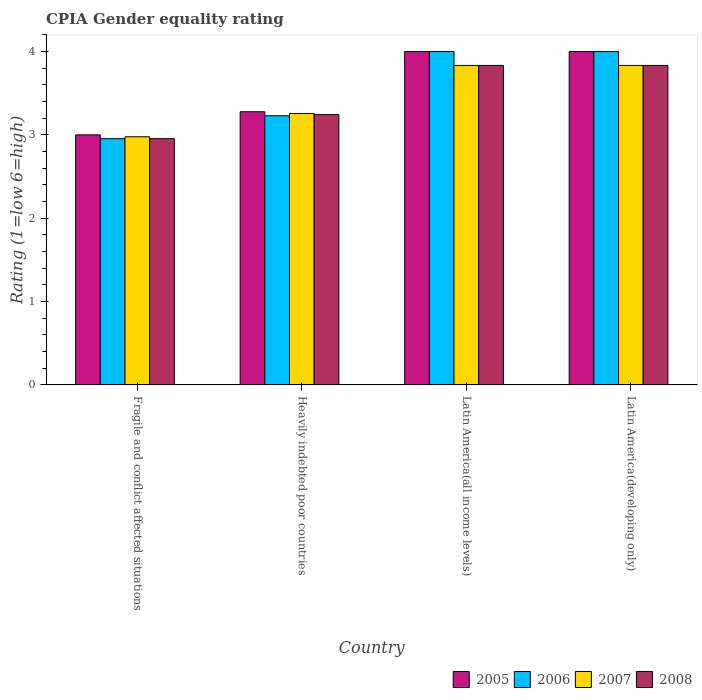How many different coloured bars are there?
Provide a short and direct response. 4. Are the number of bars on each tick of the X-axis equal?
Ensure brevity in your answer.  Yes. How many bars are there on the 4th tick from the left?
Your response must be concise. 4. What is the label of the 4th group of bars from the left?
Provide a succinct answer. Latin America(developing only). In how many cases, is the number of bars for a given country not equal to the number of legend labels?
Ensure brevity in your answer.  0. What is the CPIA rating in 2007 in Latin America(developing only)?
Provide a succinct answer. 3.83. Across all countries, what is the maximum CPIA rating in 2008?
Your answer should be compact. 3.83. Across all countries, what is the minimum CPIA rating in 2007?
Offer a terse response. 2.98. In which country was the CPIA rating in 2005 maximum?
Make the answer very short. Latin America(all income levels). In which country was the CPIA rating in 2007 minimum?
Ensure brevity in your answer.  Fragile and conflict affected situations. What is the total CPIA rating in 2008 in the graph?
Your answer should be very brief. 13.86. What is the difference between the CPIA rating in 2008 in Heavily indebted poor countries and that in Latin America(developing only)?
Make the answer very short. -0.59. What is the difference between the CPIA rating in 2006 in Fragile and conflict affected situations and the CPIA rating in 2005 in Latin America(all income levels)?
Offer a terse response. -1.05. What is the average CPIA rating in 2005 per country?
Offer a very short reply. 3.57. What is the difference between the CPIA rating of/in 2007 and CPIA rating of/in 2005 in Latin America(all income levels)?
Your answer should be very brief. -0.17. In how many countries, is the CPIA rating in 2005 greater than 3?
Make the answer very short. 3. What is the ratio of the CPIA rating in 2007 in Heavily indebted poor countries to that in Latin America(all income levels)?
Offer a very short reply. 0.85. Is the CPIA rating in 2007 in Fragile and conflict affected situations less than that in Latin America(all income levels)?
Your response must be concise. Yes. Is the difference between the CPIA rating in 2007 in Fragile and conflict affected situations and Heavily indebted poor countries greater than the difference between the CPIA rating in 2005 in Fragile and conflict affected situations and Heavily indebted poor countries?
Keep it short and to the point. No. What is the difference between the highest and the second highest CPIA rating in 2008?
Provide a succinct answer. -0.59. What is the difference between the highest and the lowest CPIA rating in 2007?
Offer a very short reply. 0.86. In how many countries, is the CPIA rating in 2007 greater than the average CPIA rating in 2007 taken over all countries?
Make the answer very short. 2. What does the 2nd bar from the left in Latin America(developing only) represents?
Your response must be concise. 2006. How many bars are there?
Offer a very short reply. 16. How many countries are there in the graph?
Provide a succinct answer. 4. Are the values on the major ticks of Y-axis written in scientific E-notation?
Offer a terse response. No. Does the graph contain grids?
Keep it short and to the point. No. What is the title of the graph?
Provide a short and direct response. CPIA Gender equality rating. What is the label or title of the X-axis?
Make the answer very short. Country. What is the label or title of the Y-axis?
Provide a short and direct response. Rating (1=low 6=high). What is the Rating (1=low 6=high) of 2005 in Fragile and conflict affected situations?
Your response must be concise. 3. What is the Rating (1=low 6=high) in 2006 in Fragile and conflict affected situations?
Ensure brevity in your answer.  2.95. What is the Rating (1=low 6=high) in 2007 in Fragile and conflict affected situations?
Your answer should be compact. 2.98. What is the Rating (1=low 6=high) in 2008 in Fragile and conflict affected situations?
Provide a succinct answer. 2.95. What is the Rating (1=low 6=high) of 2005 in Heavily indebted poor countries?
Keep it short and to the point. 3.28. What is the Rating (1=low 6=high) of 2006 in Heavily indebted poor countries?
Your answer should be compact. 3.23. What is the Rating (1=low 6=high) of 2007 in Heavily indebted poor countries?
Your answer should be very brief. 3.26. What is the Rating (1=low 6=high) in 2008 in Heavily indebted poor countries?
Your response must be concise. 3.24. What is the Rating (1=low 6=high) of 2006 in Latin America(all income levels)?
Your response must be concise. 4. What is the Rating (1=low 6=high) of 2007 in Latin America(all income levels)?
Ensure brevity in your answer.  3.83. What is the Rating (1=low 6=high) of 2008 in Latin America(all income levels)?
Offer a very short reply. 3.83. What is the Rating (1=low 6=high) in 2006 in Latin America(developing only)?
Offer a terse response. 4. What is the Rating (1=low 6=high) in 2007 in Latin America(developing only)?
Offer a terse response. 3.83. What is the Rating (1=low 6=high) of 2008 in Latin America(developing only)?
Offer a terse response. 3.83. Across all countries, what is the maximum Rating (1=low 6=high) in 2007?
Make the answer very short. 3.83. Across all countries, what is the maximum Rating (1=low 6=high) of 2008?
Offer a very short reply. 3.83. Across all countries, what is the minimum Rating (1=low 6=high) of 2006?
Offer a very short reply. 2.95. Across all countries, what is the minimum Rating (1=low 6=high) of 2007?
Your answer should be compact. 2.98. Across all countries, what is the minimum Rating (1=low 6=high) in 2008?
Provide a short and direct response. 2.95. What is the total Rating (1=low 6=high) in 2005 in the graph?
Your answer should be very brief. 14.28. What is the total Rating (1=low 6=high) in 2006 in the graph?
Make the answer very short. 14.18. What is the total Rating (1=low 6=high) of 2007 in the graph?
Ensure brevity in your answer.  13.9. What is the total Rating (1=low 6=high) in 2008 in the graph?
Your response must be concise. 13.86. What is the difference between the Rating (1=low 6=high) in 2005 in Fragile and conflict affected situations and that in Heavily indebted poor countries?
Your response must be concise. -0.28. What is the difference between the Rating (1=low 6=high) in 2006 in Fragile and conflict affected situations and that in Heavily indebted poor countries?
Keep it short and to the point. -0.28. What is the difference between the Rating (1=low 6=high) in 2007 in Fragile and conflict affected situations and that in Heavily indebted poor countries?
Your answer should be compact. -0.28. What is the difference between the Rating (1=low 6=high) in 2008 in Fragile and conflict affected situations and that in Heavily indebted poor countries?
Your answer should be compact. -0.29. What is the difference between the Rating (1=low 6=high) in 2005 in Fragile and conflict affected situations and that in Latin America(all income levels)?
Ensure brevity in your answer.  -1. What is the difference between the Rating (1=low 6=high) in 2006 in Fragile and conflict affected situations and that in Latin America(all income levels)?
Your response must be concise. -1.05. What is the difference between the Rating (1=low 6=high) in 2007 in Fragile and conflict affected situations and that in Latin America(all income levels)?
Give a very brief answer. -0.86. What is the difference between the Rating (1=low 6=high) in 2008 in Fragile and conflict affected situations and that in Latin America(all income levels)?
Provide a succinct answer. -0.88. What is the difference between the Rating (1=low 6=high) of 2005 in Fragile and conflict affected situations and that in Latin America(developing only)?
Provide a short and direct response. -1. What is the difference between the Rating (1=low 6=high) of 2006 in Fragile and conflict affected situations and that in Latin America(developing only)?
Provide a short and direct response. -1.05. What is the difference between the Rating (1=low 6=high) of 2007 in Fragile and conflict affected situations and that in Latin America(developing only)?
Ensure brevity in your answer.  -0.86. What is the difference between the Rating (1=low 6=high) in 2008 in Fragile and conflict affected situations and that in Latin America(developing only)?
Offer a terse response. -0.88. What is the difference between the Rating (1=low 6=high) in 2005 in Heavily indebted poor countries and that in Latin America(all income levels)?
Offer a very short reply. -0.72. What is the difference between the Rating (1=low 6=high) in 2006 in Heavily indebted poor countries and that in Latin America(all income levels)?
Keep it short and to the point. -0.77. What is the difference between the Rating (1=low 6=high) of 2007 in Heavily indebted poor countries and that in Latin America(all income levels)?
Provide a short and direct response. -0.58. What is the difference between the Rating (1=low 6=high) of 2008 in Heavily indebted poor countries and that in Latin America(all income levels)?
Offer a terse response. -0.59. What is the difference between the Rating (1=low 6=high) of 2005 in Heavily indebted poor countries and that in Latin America(developing only)?
Keep it short and to the point. -0.72. What is the difference between the Rating (1=low 6=high) of 2006 in Heavily indebted poor countries and that in Latin America(developing only)?
Provide a succinct answer. -0.77. What is the difference between the Rating (1=low 6=high) in 2007 in Heavily indebted poor countries and that in Latin America(developing only)?
Ensure brevity in your answer.  -0.58. What is the difference between the Rating (1=low 6=high) of 2008 in Heavily indebted poor countries and that in Latin America(developing only)?
Provide a short and direct response. -0.59. What is the difference between the Rating (1=low 6=high) of 2005 in Latin America(all income levels) and that in Latin America(developing only)?
Make the answer very short. 0. What is the difference between the Rating (1=low 6=high) in 2007 in Latin America(all income levels) and that in Latin America(developing only)?
Offer a terse response. 0. What is the difference between the Rating (1=low 6=high) of 2008 in Latin America(all income levels) and that in Latin America(developing only)?
Provide a succinct answer. 0. What is the difference between the Rating (1=low 6=high) of 2005 in Fragile and conflict affected situations and the Rating (1=low 6=high) of 2006 in Heavily indebted poor countries?
Your answer should be very brief. -0.23. What is the difference between the Rating (1=low 6=high) of 2005 in Fragile and conflict affected situations and the Rating (1=low 6=high) of 2007 in Heavily indebted poor countries?
Ensure brevity in your answer.  -0.26. What is the difference between the Rating (1=low 6=high) in 2005 in Fragile and conflict affected situations and the Rating (1=low 6=high) in 2008 in Heavily indebted poor countries?
Keep it short and to the point. -0.24. What is the difference between the Rating (1=low 6=high) of 2006 in Fragile and conflict affected situations and the Rating (1=low 6=high) of 2007 in Heavily indebted poor countries?
Provide a short and direct response. -0.3. What is the difference between the Rating (1=low 6=high) of 2006 in Fragile and conflict affected situations and the Rating (1=low 6=high) of 2008 in Heavily indebted poor countries?
Ensure brevity in your answer.  -0.29. What is the difference between the Rating (1=low 6=high) of 2007 in Fragile and conflict affected situations and the Rating (1=low 6=high) of 2008 in Heavily indebted poor countries?
Your answer should be compact. -0.27. What is the difference between the Rating (1=low 6=high) of 2005 in Fragile and conflict affected situations and the Rating (1=low 6=high) of 2006 in Latin America(all income levels)?
Make the answer very short. -1. What is the difference between the Rating (1=low 6=high) in 2006 in Fragile and conflict affected situations and the Rating (1=low 6=high) in 2007 in Latin America(all income levels)?
Your answer should be compact. -0.88. What is the difference between the Rating (1=low 6=high) in 2006 in Fragile and conflict affected situations and the Rating (1=low 6=high) in 2008 in Latin America(all income levels)?
Provide a succinct answer. -0.88. What is the difference between the Rating (1=low 6=high) in 2007 in Fragile and conflict affected situations and the Rating (1=low 6=high) in 2008 in Latin America(all income levels)?
Provide a succinct answer. -0.86. What is the difference between the Rating (1=low 6=high) in 2005 in Fragile and conflict affected situations and the Rating (1=low 6=high) in 2006 in Latin America(developing only)?
Provide a short and direct response. -1. What is the difference between the Rating (1=low 6=high) of 2005 in Fragile and conflict affected situations and the Rating (1=low 6=high) of 2007 in Latin America(developing only)?
Your response must be concise. -0.83. What is the difference between the Rating (1=low 6=high) of 2006 in Fragile and conflict affected situations and the Rating (1=low 6=high) of 2007 in Latin America(developing only)?
Offer a terse response. -0.88. What is the difference between the Rating (1=low 6=high) in 2006 in Fragile and conflict affected situations and the Rating (1=low 6=high) in 2008 in Latin America(developing only)?
Your answer should be very brief. -0.88. What is the difference between the Rating (1=low 6=high) in 2007 in Fragile and conflict affected situations and the Rating (1=low 6=high) in 2008 in Latin America(developing only)?
Give a very brief answer. -0.86. What is the difference between the Rating (1=low 6=high) in 2005 in Heavily indebted poor countries and the Rating (1=low 6=high) in 2006 in Latin America(all income levels)?
Ensure brevity in your answer.  -0.72. What is the difference between the Rating (1=low 6=high) in 2005 in Heavily indebted poor countries and the Rating (1=low 6=high) in 2007 in Latin America(all income levels)?
Offer a terse response. -0.56. What is the difference between the Rating (1=low 6=high) of 2005 in Heavily indebted poor countries and the Rating (1=low 6=high) of 2008 in Latin America(all income levels)?
Ensure brevity in your answer.  -0.56. What is the difference between the Rating (1=low 6=high) of 2006 in Heavily indebted poor countries and the Rating (1=low 6=high) of 2007 in Latin America(all income levels)?
Ensure brevity in your answer.  -0.6. What is the difference between the Rating (1=low 6=high) of 2006 in Heavily indebted poor countries and the Rating (1=low 6=high) of 2008 in Latin America(all income levels)?
Provide a succinct answer. -0.6. What is the difference between the Rating (1=low 6=high) in 2007 in Heavily indebted poor countries and the Rating (1=low 6=high) in 2008 in Latin America(all income levels)?
Offer a terse response. -0.58. What is the difference between the Rating (1=low 6=high) in 2005 in Heavily indebted poor countries and the Rating (1=low 6=high) in 2006 in Latin America(developing only)?
Keep it short and to the point. -0.72. What is the difference between the Rating (1=low 6=high) of 2005 in Heavily indebted poor countries and the Rating (1=low 6=high) of 2007 in Latin America(developing only)?
Give a very brief answer. -0.56. What is the difference between the Rating (1=low 6=high) of 2005 in Heavily indebted poor countries and the Rating (1=low 6=high) of 2008 in Latin America(developing only)?
Provide a short and direct response. -0.56. What is the difference between the Rating (1=low 6=high) in 2006 in Heavily indebted poor countries and the Rating (1=low 6=high) in 2007 in Latin America(developing only)?
Provide a short and direct response. -0.6. What is the difference between the Rating (1=low 6=high) in 2006 in Heavily indebted poor countries and the Rating (1=low 6=high) in 2008 in Latin America(developing only)?
Give a very brief answer. -0.6. What is the difference between the Rating (1=low 6=high) of 2007 in Heavily indebted poor countries and the Rating (1=low 6=high) of 2008 in Latin America(developing only)?
Ensure brevity in your answer.  -0.58. What is the difference between the Rating (1=low 6=high) in 2005 in Latin America(all income levels) and the Rating (1=low 6=high) in 2006 in Latin America(developing only)?
Your answer should be very brief. 0. What is the difference between the Rating (1=low 6=high) of 2005 in Latin America(all income levels) and the Rating (1=low 6=high) of 2008 in Latin America(developing only)?
Offer a terse response. 0.17. What is the average Rating (1=low 6=high) in 2005 per country?
Give a very brief answer. 3.57. What is the average Rating (1=low 6=high) in 2006 per country?
Provide a short and direct response. 3.55. What is the average Rating (1=low 6=high) in 2007 per country?
Give a very brief answer. 3.48. What is the average Rating (1=low 6=high) of 2008 per country?
Offer a very short reply. 3.47. What is the difference between the Rating (1=low 6=high) of 2005 and Rating (1=low 6=high) of 2006 in Fragile and conflict affected situations?
Ensure brevity in your answer.  0.05. What is the difference between the Rating (1=low 6=high) in 2005 and Rating (1=low 6=high) in 2007 in Fragile and conflict affected situations?
Give a very brief answer. 0.02. What is the difference between the Rating (1=low 6=high) in 2005 and Rating (1=low 6=high) in 2008 in Fragile and conflict affected situations?
Provide a succinct answer. 0.05. What is the difference between the Rating (1=low 6=high) in 2006 and Rating (1=low 6=high) in 2007 in Fragile and conflict affected situations?
Offer a very short reply. -0.02. What is the difference between the Rating (1=low 6=high) in 2006 and Rating (1=low 6=high) in 2008 in Fragile and conflict affected situations?
Offer a very short reply. 0. What is the difference between the Rating (1=low 6=high) in 2007 and Rating (1=low 6=high) in 2008 in Fragile and conflict affected situations?
Offer a terse response. 0.02. What is the difference between the Rating (1=low 6=high) in 2005 and Rating (1=low 6=high) in 2006 in Heavily indebted poor countries?
Make the answer very short. 0.05. What is the difference between the Rating (1=low 6=high) in 2005 and Rating (1=low 6=high) in 2007 in Heavily indebted poor countries?
Make the answer very short. 0.02. What is the difference between the Rating (1=low 6=high) in 2005 and Rating (1=low 6=high) in 2008 in Heavily indebted poor countries?
Give a very brief answer. 0.03. What is the difference between the Rating (1=low 6=high) of 2006 and Rating (1=low 6=high) of 2007 in Heavily indebted poor countries?
Keep it short and to the point. -0.03. What is the difference between the Rating (1=low 6=high) in 2006 and Rating (1=low 6=high) in 2008 in Heavily indebted poor countries?
Offer a very short reply. -0.01. What is the difference between the Rating (1=low 6=high) in 2007 and Rating (1=low 6=high) in 2008 in Heavily indebted poor countries?
Your answer should be compact. 0.01. What is the difference between the Rating (1=low 6=high) in 2005 and Rating (1=low 6=high) in 2006 in Latin America(all income levels)?
Give a very brief answer. 0. What is the difference between the Rating (1=low 6=high) in 2005 and Rating (1=low 6=high) in 2006 in Latin America(developing only)?
Offer a terse response. 0. What is the difference between the Rating (1=low 6=high) in 2005 and Rating (1=low 6=high) in 2007 in Latin America(developing only)?
Offer a terse response. 0.17. What is the difference between the Rating (1=low 6=high) in 2005 and Rating (1=low 6=high) in 2008 in Latin America(developing only)?
Provide a succinct answer. 0.17. What is the ratio of the Rating (1=low 6=high) of 2005 in Fragile and conflict affected situations to that in Heavily indebted poor countries?
Offer a terse response. 0.92. What is the ratio of the Rating (1=low 6=high) in 2006 in Fragile and conflict affected situations to that in Heavily indebted poor countries?
Your response must be concise. 0.91. What is the ratio of the Rating (1=low 6=high) of 2007 in Fragile and conflict affected situations to that in Heavily indebted poor countries?
Give a very brief answer. 0.91. What is the ratio of the Rating (1=low 6=high) in 2008 in Fragile and conflict affected situations to that in Heavily indebted poor countries?
Provide a succinct answer. 0.91. What is the ratio of the Rating (1=low 6=high) in 2005 in Fragile and conflict affected situations to that in Latin America(all income levels)?
Ensure brevity in your answer.  0.75. What is the ratio of the Rating (1=low 6=high) in 2006 in Fragile and conflict affected situations to that in Latin America(all income levels)?
Provide a succinct answer. 0.74. What is the ratio of the Rating (1=low 6=high) of 2007 in Fragile and conflict affected situations to that in Latin America(all income levels)?
Offer a terse response. 0.78. What is the ratio of the Rating (1=low 6=high) of 2008 in Fragile and conflict affected situations to that in Latin America(all income levels)?
Offer a terse response. 0.77. What is the ratio of the Rating (1=low 6=high) in 2006 in Fragile and conflict affected situations to that in Latin America(developing only)?
Keep it short and to the point. 0.74. What is the ratio of the Rating (1=low 6=high) of 2007 in Fragile and conflict affected situations to that in Latin America(developing only)?
Give a very brief answer. 0.78. What is the ratio of the Rating (1=low 6=high) in 2008 in Fragile and conflict affected situations to that in Latin America(developing only)?
Your response must be concise. 0.77. What is the ratio of the Rating (1=low 6=high) of 2005 in Heavily indebted poor countries to that in Latin America(all income levels)?
Give a very brief answer. 0.82. What is the ratio of the Rating (1=low 6=high) of 2006 in Heavily indebted poor countries to that in Latin America(all income levels)?
Offer a terse response. 0.81. What is the ratio of the Rating (1=low 6=high) of 2007 in Heavily indebted poor countries to that in Latin America(all income levels)?
Give a very brief answer. 0.85. What is the ratio of the Rating (1=low 6=high) of 2008 in Heavily indebted poor countries to that in Latin America(all income levels)?
Ensure brevity in your answer.  0.85. What is the ratio of the Rating (1=low 6=high) in 2005 in Heavily indebted poor countries to that in Latin America(developing only)?
Provide a short and direct response. 0.82. What is the ratio of the Rating (1=low 6=high) in 2006 in Heavily indebted poor countries to that in Latin America(developing only)?
Ensure brevity in your answer.  0.81. What is the ratio of the Rating (1=low 6=high) of 2007 in Heavily indebted poor countries to that in Latin America(developing only)?
Make the answer very short. 0.85. What is the ratio of the Rating (1=low 6=high) in 2008 in Heavily indebted poor countries to that in Latin America(developing only)?
Offer a terse response. 0.85. What is the ratio of the Rating (1=low 6=high) of 2007 in Latin America(all income levels) to that in Latin America(developing only)?
Give a very brief answer. 1. What is the ratio of the Rating (1=low 6=high) in 2008 in Latin America(all income levels) to that in Latin America(developing only)?
Offer a very short reply. 1. What is the difference between the highest and the second highest Rating (1=low 6=high) in 2005?
Provide a short and direct response. 0. What is the difference between the highest and the second highest Rating (1=low 6=high) of 2007?
Offer a terse response. 0. What is the difference between the highest and the second highest Rating (1=low 6=high) in 2008?
Offer a terse response. 0. What is the difference between the highest and the lowest Rating (1=low 6=high) of 2006?
Provide a short and direct response. 1.05. What is the difference between the highest and the lowest Rating (1=low 6=high) of 2007?
Your answer should be compact. 0.86. What is the difference between the highest and the lowest Rating (1=low 6=high) in 2008?
Your answer should be compact. 0.88. 